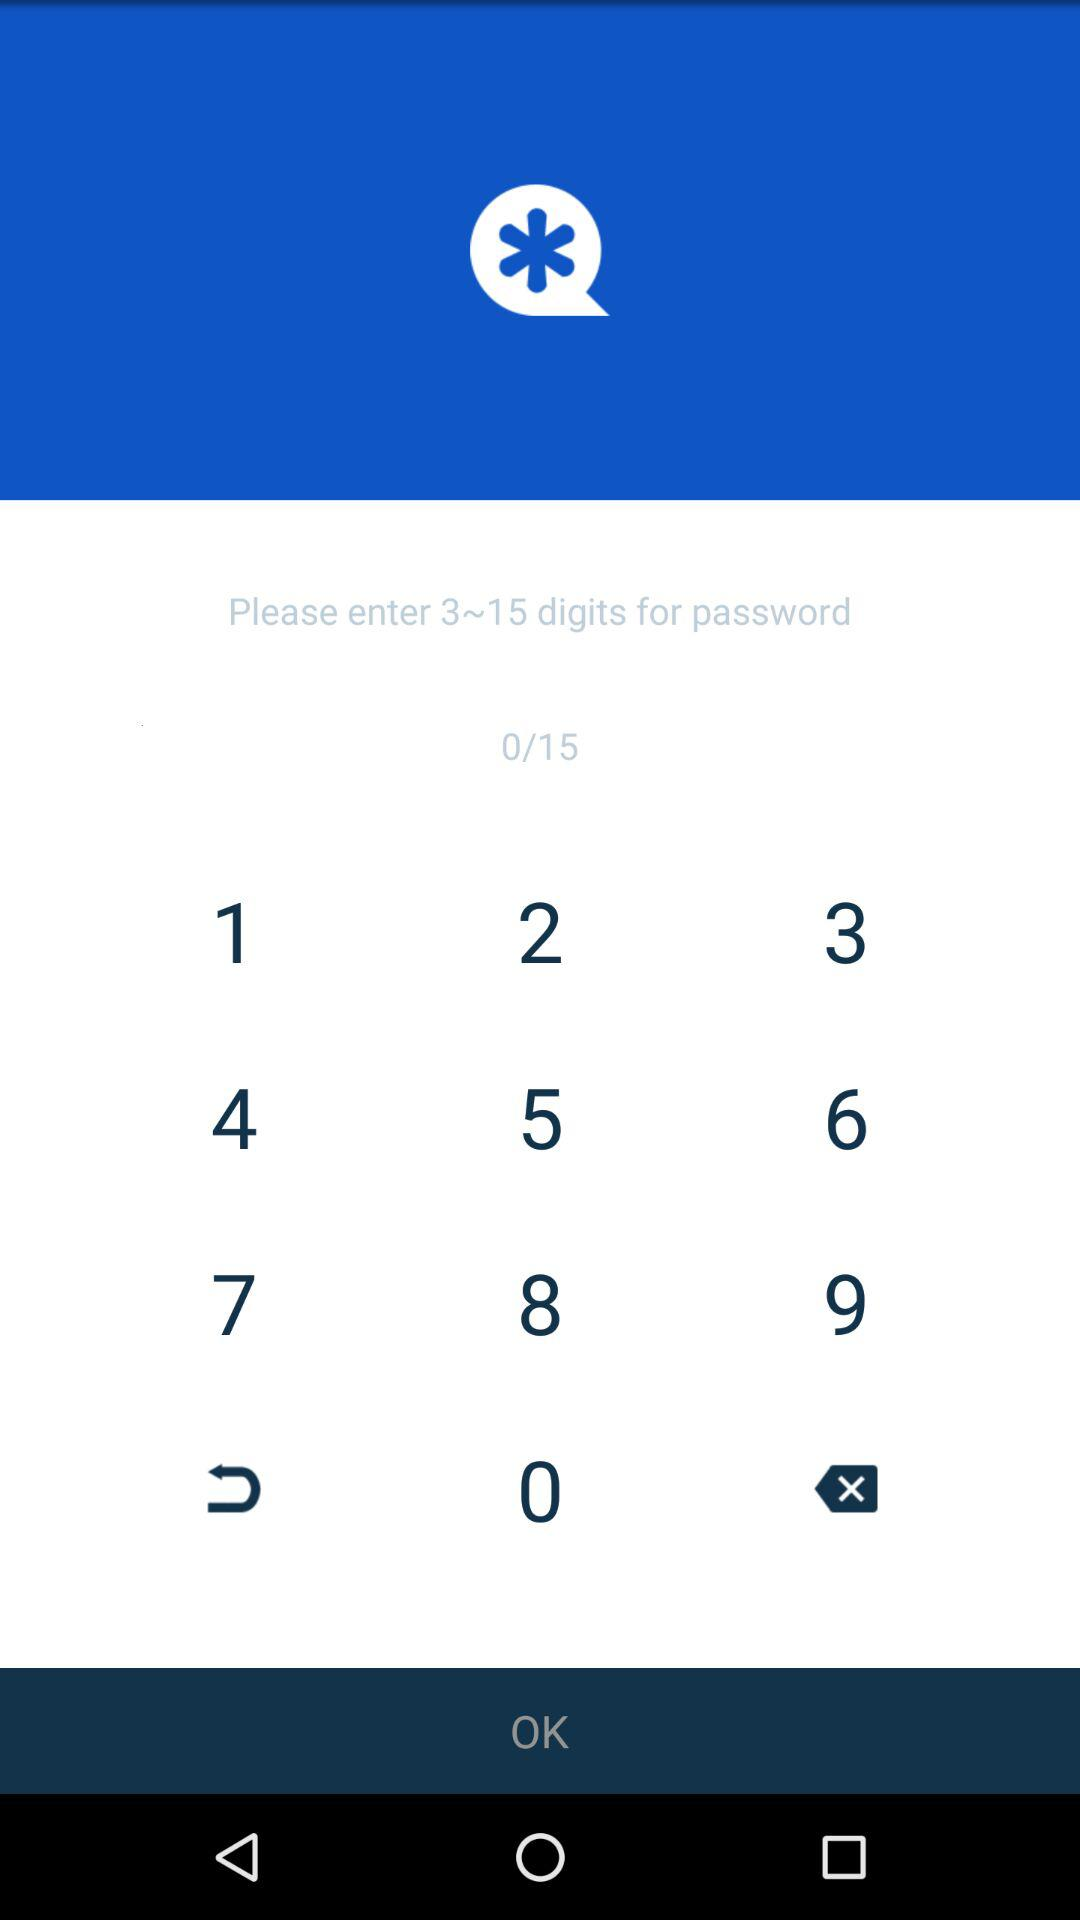What is the maximum digit number? The maximum digit number is 15. 